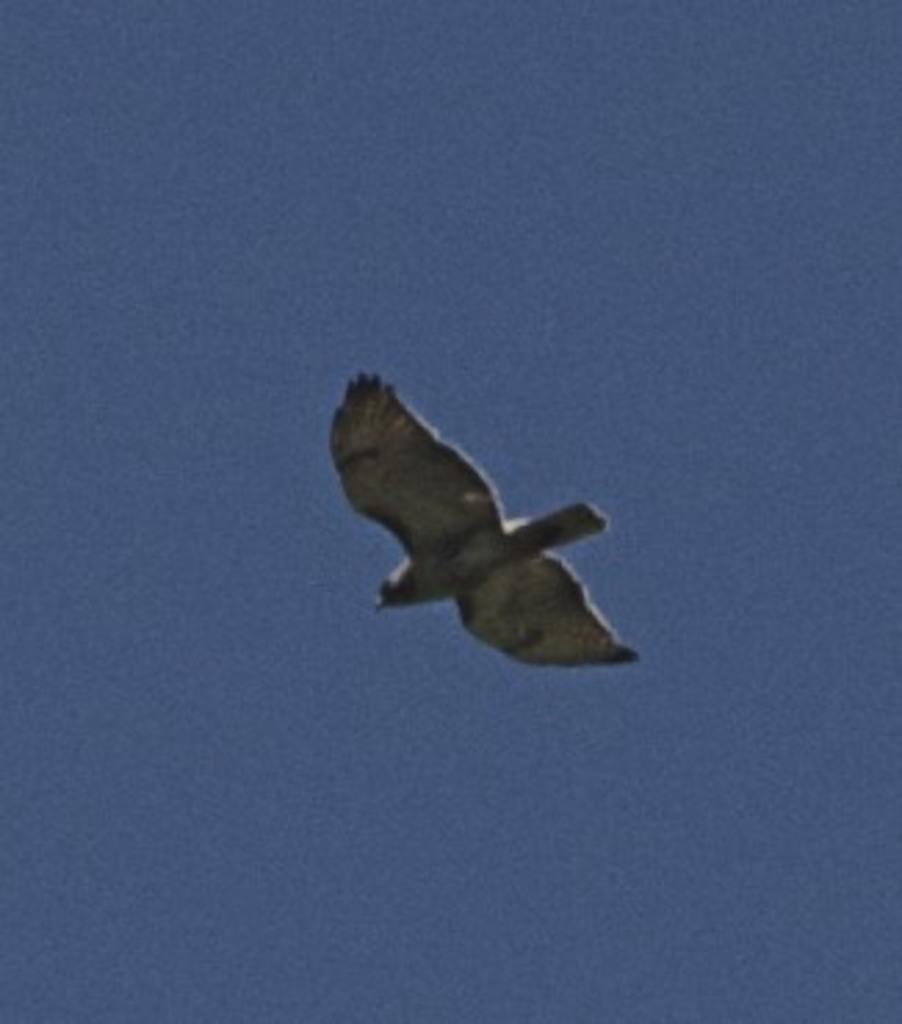Where was the image taken? The image was taken outdoors. What can be seen in the background of the image? There is a sky visible in the background of the image. What is happening in the sky in the middle of the image? A bird is flying in the sky in the middle of the image. How many chairs are placed on the road in the image? There are no chairs or roads present in the image; it features a bird flying in the sky. 